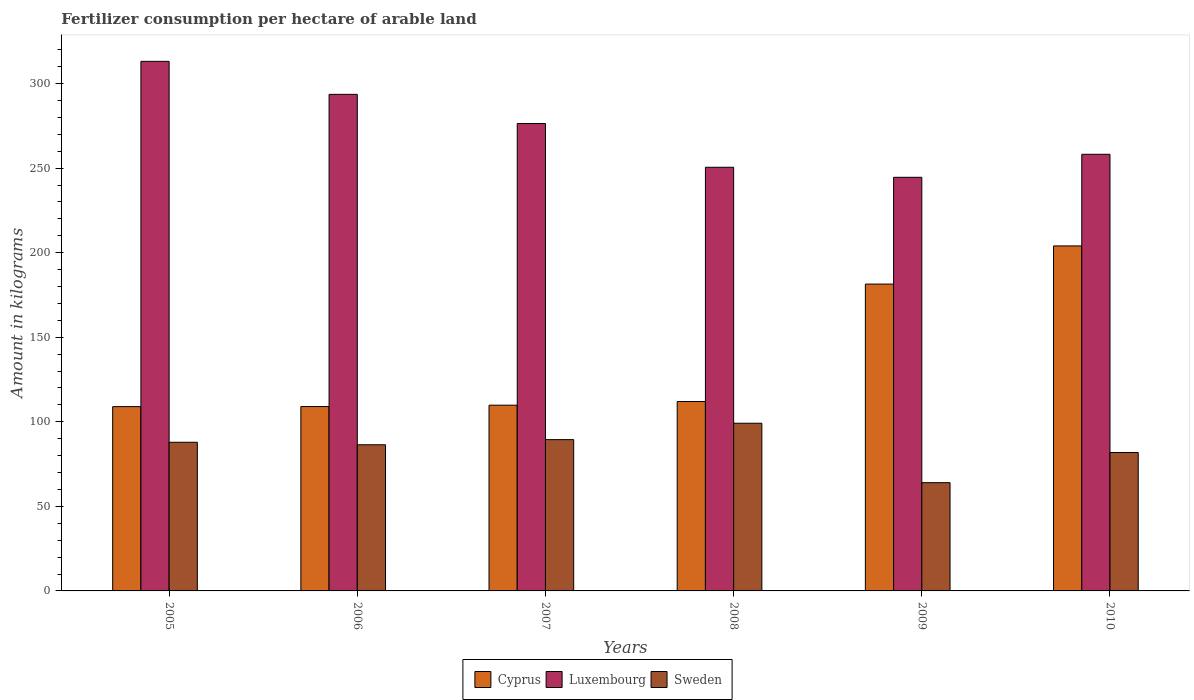How many different coloured bars are there?
Offer a terse response. 3. Are the number of bars per tick equal to the number of legend labels?
Ensure brevity in your answer.  Yes. How many bars are there on the 5th tick from the left?
Your response must be concise. 3. In how many cases, is the number of bars for a given year not equal to the number of legend labels?
Your response must be concise. 0. What is the amount of fertilizer consumption in Luxembourg in 2007?
Offer a terse response. 276.41. Across all years, what is the maximum amount of fertilizer consumption in Cyprus?
Provide a succinct answer. 204.01. Across all years, what is the minimum amount of fertilizer consumption in Cyprus?
Provide a succinct answer. 108.98. In which year was the amount of fertilizer consumption in Cyprus maximum?
Your answer should be compact. 2010. What is the total amount of fertilizer consumption in Cyprus in the graph?
Keep it short and to the point. 825.31. What is the difference between the amount of fertilizer consumption in Sweden in 2007 and that in 2010?
Your response must be concise. 7.61. What is the difference between the amount of fertilizer consumption in Luxembourg in 2008 and the amount of fertilizer consumption in Cyprus in 2005?
Offer a terse response. 141.54. What is the average amount of fertilizer consumption in Cyprus per year?
Ensure brevity in your answer.  137.55. In the year 2008, what is the difference between the amount of fertilizer consumption in Cyprus and amount of fertilizer consumption in Sweden?
Your answer should be very brief. 12.85. In how many years, is the amount of fertilizer consumption in Luxembourg greater than 30 kg?
Offer a very short reply. 6. What is the ratio of the amount of fertilizer consumption in Cyprus in 2006 to that in 2007?
Offer a very short reply. 0.99. Is the amount of fertilizer consumption in Luxembourg in 2005 less than that in 2009?
Offer a terse response. No. What is the difference between the highest and the second highest amount of fertilizer consumption in Luxembourg?
Your answer should be very brief. 19.52. What is the difference between the highest and the lowest amount of fertilizer consumption in Sweden?
Provide a succinct answer. 35.15. In how many years, is the amount of fertilizer consumption in Luxembourg greater than the average amount of fertilizer consumption in Luxembourg taken over all years?
Give a very brief answer. 3. Is the sum of the amount of fertilizer consumption in Sweden in 2006 and 2008 greater than the maximum amount of fertilizer consumption in Cyprus across all years?
Make the answer very short. No. How many years are there in the graph?
Make the answer very short. 6. What is the difference between two consecutive major ticks on the Y-axis?
Provide a short and direct response. 50. Are the values on the major ticks of Y-axis written in scientific E-notation?
Your response must be concise. No. Does the graph contain any zero values?
Provide a short and direct response. No. Where does the legend appear in the graph?
Your answer should be compact. Bottom center. What is the title of the graph?
Make the answer very short. Fertilizer consumption per hectare of arable land. Does "Bangladesh" appear as one of the legend labels in the graph?
Keep it short and to the point. No. What is the label or title of the X-axis?
Provide a succinct answer. Years. What is the label or title of the Y-axis?
Ensure brevity in your answer.  Amount in kilograms. What is the Amount in kilograms in Cyprus in 2005?
Ensure brevity in your answer.  108.98. What is the Amount in kilograms of Luxembourg in 2005?
Offer a terse response. 313.15. What is the Amount in kilograms of Sweden in 2005?
Your response must be concise. 87.9. What is the Amount in kilograms of Cyprus in 2006?
Your response must be concise. 109.03. What is the Amount in kilograms of Luxembourg in 2006?
Provide a succinct answer. 293.63. What is the Amount in kilograms of Sweden in 2006?
Provide a short and direct response. 86.42. What is the Amount in kilograms of Cyprus in 2007?
Give a very brief answer. 109.84. What is the Amount in kilograms of Luxembourg in 2007?
Your answer should be compact. 276.41. What is the Amount in kilograms of Sweden in 2007?
Keep it short and to the point. 89.47. What is the Amount in kilograms in Cyprus in 2008?
Your answer should be compact. 112.01. What is the Amount in kilograms of Luxembourg in 2008?
Make the answer very short. 250.52. What is the Amount in kilograms in Sweden in 2008?
Offer a terse response. 99.16. What is the Amount in kilograms of Cyprus in 2009?
Provide a short and direct response. 181.45. What is the Amount in kilograms of Luxembourg in 2009?
Make the answer very short. 244.58. What is the Amount in kilograms in Sweden in 2009?
Give a very brief answer. 64.01. What is the Amount in kilograms of Cyprus in 2010?
Keep it short and to the point. 204.01. What is the Amount in kilograms of Luxembourg in 2010?
Your answer should be very brief. 258.19. What is the Amount in kilograms in Sweden in 2010?
Provide a succinct answer. 81.85. Across all years, what is the maximum Amount in kilograms in Cyprus?
Offer a very short reply. 204.01. Across all years, what is the maximum Amount in kilograms in Luxembourg?
Ensure brevity in your answer.  313.15. Across all years, what is the maximum Amount in kilograms of Sweden?
Offer a very short reply. 99.16. Across all years, what is the minimum Amount in kilograms of Cyprus?
Keep it short and to the point. 108.98. Across all years, what is the minimum Amount in kilograms in Luxembourg?
Your answer should be compact. 244.58. Across all years, what is the minimum Amount in kilograms in Sweden?
Make the answer very short. 64.01. What is the total Amount in kilograms in Cyprus in the graph?
Your answer should be very brief. 825.31. What is the total Amount in kilograms of Luxembourg in the graph?
Provide a short and direct response. 1636.49. What is the total Amount in kilograms in Sweden in the graph?
Give a very brief answer. 508.81. What is the difference between the Amount in kilograms of Cyprus in 2005 and that in 2006?
Your answer should be compact. -0.05. What is the difference between the Amount in kilograms of Luxembourg in 2005 and that in 2006?
Your answer should be compact. 19.52. What is the difference between the Amount in kilograms of Sweden in 2005 and that in 2006?
Offer a terse response. 1.48. What is the difference between the Amount in kilograms of Cyprus in 2005 and that in 2007?
Your answer should be very brief. -0.86. What is the difference between the Amount in kilograms in Luxembourg in 2005 and that in 2007?
Make the answer very short. 36.74. What is the difference between the Amount in kilograms in Sweden in 2005 and that in 2007?
Ensure brevity in your answer.  -1.57. What is the difference between the Amount in kilograms in Cyprus in 2005 and that in 2008?
Offer a terse response. -3.04. What is the difference between the Amount in kilograms of Luxembourg in 2005 and that in 2008?
Keep it short and to the point. 62.63. What is the difference between the Amount in kilograms of Sweden in 2005 and that in 2008?
Give a very brief answer. -11.26. What is the difference between the Amount in kilograms in Cyprus in 2005 and that in 2009?
Make the answer very short. -72.47. What is the difference between the Amount in kilograms in Luxembourg in 2005 and that in 2009?
Your response must be concise. 68.57. What is the difference between the Amount in kilograms of Sweden in 2005 and that in 2009?
Give a very brief answer. 23.89. What is the difference between the Amount in kilograms of Cyprus in 2005 and that in 2010?
Offer a very short reply. -95.03. What is the difference between the Amount in kilograms of Luxembourg in 2005 and that in 2010?
Give a very brief answer. 54.96. What is the difference between the Amount in kilograms in Sweden in 2005 and that in 2010?
Your answer should be very brief. 6.04. What is the difference between the Amount in kilograms of Cyprus in 2006 and that in 2007?
Make the answer very short. -0.81. What is the difference between the Amount in kilograms of Luxembourg in 2006 and that in 2007?
Offer a terse response. 17.22. What is the difference between the Amount in kilograms in Sweden in 2006 and that in 2007?
Offer a terse response. -3.05. What is the difference between the Amount in kilograms in Cyprus in 2006 and that in 2008?
Give a very brief answer. -2.99. What is the difference between the Amount in kilograms of Luxembourg in 2006 and that in 2008?
Offer a terse response. 43.12. What is the difference between the Amount in kilograms in Sweden in 2006 and that in 2008?
Offer a very short reply. -12.74. What is the difference between the Amount in kilograms of Cyprus in 2006 and that in 2009?
Offer a very short reply. -72.42. What is the difference between the Amount in kilograms in Luxembourg in 2006 and that in 2009?
Your answer should be compact. 49.05. What is the difference between the Amount in kilograms in Sweden in 2006 and that in 2009?
Offer a very short reply. 22.41. What is the difference between the Amount in kilograms in Cyprus in 2006 and that in 2010?
Keep it short and to the point. -94.98. What is the difference between the Amount in kilograms of Luxembourg in 2006 and that in 2010?
Provide a succinct answer. 35.44. What is the difference between the Amount in kilograms of Sweden in 2006 and that in 2010?
Ensure brevity in your answer.  4.57. What is the difference between the Amount in kilograms of Cyprus in 2007 and that in 2008?
Ensure brevity in your answer.  -2.18. What is the difference between the Amount in kilograms of Luxembourg in 2007 and that in 2008?
Give a very brief answer. 25.89. What is the difference between the Amount in kilograms in Sweden in 2007 and that in 2008?
Your response must be concise. -9.7. What is the difference between the Amount in kilograms of Cyprus in 2007 and that in 2009?
Make the answer very short. -71.61. What is the difference between the Amount in kilograms in Luxembourg in 2007 and that in 2009?
Keep it short and to the point. 31.83. What is the difference between the Amount in kilograms in Sweden in 2007 and that in 2009?
Offer a terse response. 25.46. What is the difference between the Amount in kilograms in Cyprus in 2007 and that in 2010?
Ensure brevity in your answer.  -94.17. What is the difference between the Amount in kilograms of Luxembourg in 2007 and that in 2010?
Keep it short and to the point. 18.22. What is the difference between the Amount in kilograms of Sweden in 2007 and that in 2010?
Give a very brief answer. 7.61. What is the difference between the Amount in kilograms in Cyprus in 2008 and that in 2009?
Give a very brief answer. -69.44. What is the difference between the Amount in kilograms of Luxembourg in 2008 and that in 2009?
Your answer should be compact. 5.93. What is the difference between the Amount in kilograms of Sweden in 2008 and that in 2009?
Your answer should be very brief. 35.15. What is the difference between the Amount in kilograms of Cyprus in 2008 and that in 2010?
Ensure brevity in your answer.  -91.99. What is the difference between the Amount in kilograms of Luxembourg in 2008 and that in 2010?
Make the answer very short. -7.68. What is the difference between the Amount in kilograms of Sweden in 2008 and that in 2010?
Your answer should be very brief. 17.31. What is the difference between the Amount in kilograms of Cyprus in 2009 and that in 2010?
Provide a succinct answer. -22.56. What is the difference between the Amount in kilograms in Luxembourg in 2009 and that in 2010?
Give a very brief answer. -13.61. What is the difference between the Amount in kilograms in Sweden in 2009 and that in 2010?
Provide a short and direct response. -17.85. What is the difference between the Amount in kilograms in Cyprus in 2005 and the Amount in kilograms in Luxembourg in 2006?
Keep it short and to the point. -184.66. What is the difference between the Amount in kilograms in Cyprus in 2005 and the Amount in kilograms in Sweden in 2006?
Your answer should be compact. 22.56. What is the difference between the Amount in kilograms in Luxembourg in 2005 and the Amount in kilograms in Sweden in 2006?
Keep it short and to the point. 226.73. What is the difference between the Amount in kilograms in Cyprus in 2005 and the Amount in kilograms in Luxembourg in 2007?
Your answer should be very brief. -167.43. What is the difference between the Amount in kilograms in Cyprus in 2005 and the Amount in kilograms in Sweden in 2007?
Provide a short and direct response. 19.51. What is the difference between the Amount in kilograms of Luxembourg in 2005 and the Amount in kilograms of Sweden in 2007?
Make the answer very short. 223.68. What is the difference between the Amount in kilograms in Cyprus in 2005 and the Amount in kilograms in Luxembourg in 2008?
Make the answer very short. -141.54. What is the difference between the Amount in kilograms of Cyprus in 2005 and the Amount in kilograms of Sweden in 2008?
Ensure brevity in your answer.  9.81. What is the difference between the Amount in kilograms of Luxembourg in 2005 and the Amount in kilograms of Sweden in 2008?
Your answer should be compact. 213.99. What is the difference between the Amount in kilograms in Cyprus in 2005 and the Amount in kilograms in Luxembourg in 2009?
Provide a short and direct response. -135.61. What is the difference between the Amount in kilograms in Cyprus in 2005 and the Amount in kilograms in Sweden in 2009?
Your answer should be compact. 44.97. What is the difference between the Amount in kilograms of Luxembourg in 2005 and the Amount in kilograms of Sweden in 2009?
Provide a succinct answer. 249.14. What is the difference between the Amount in kilograms of Cyprus in 2005 and the Amount in kilograms of Luxembourg in 2010?
Your response must be concise. -149.22. What is the difference between the Amount in kilograms in Cyprus in 2005 and the Amount in kilograms in Sweden in 2010?
Provide a short and direct response. 27.12. What is the difference between the Amount in kilograms in Luxembourg in 2005 and the Amount in kilograms in Sweden in 2010?
Your answer should be compact. 231.3. What is the difference between the Amount in kilograms of Cyprus in 2006 and the Amount in kilograms of Luxembourg in 2007?
Ensure brevity in your answer.  -167.38. What is the difference between the Amount in kilograms of Cyprus in 2006 and the Amount in kilograms of Sweden in 2007?
Make the answer very short. 19.56. What is the difference between the Amount in kilograms in Luxembourg in 2006 and the Amount in kilograms in Sweden in 2007?
Ensure brevity in your answer.  204.17. What is the difference between the Amount in kilograms in Cyprus in 2006 and the Amount in kilograms in Luxembourg in 2008?
Keep it short and to the point. -141.49. What is the difference between the Amount in kilograms in Cyprus in 2006 and the Amount in kilograms in Sweden in 2008?
Give a very brief answer. 9.86. What is the difference between the Amount in kilograms in Luxembourg in 2006 and the Amount in kilograms in Sweden in 2008?
Your response must be concise. 194.47. What is the difference between the Amount in kilograms of Cyprus in 2006 and the Amount in kilograms of Luxembourg in 2009?
Make the answer very short. -135.56. What is the difference between the Amount in kilograms in Cyprus in 2006 and the Amount in kilograms in Sweden in 2009?
Offer a terse response. 45.02. What is the difference between the Amount in kilograms in Luxembourg in 2006 and the Amount in kilograms in Sweden in 2009?
Offer a very short reply. 229.62. What is the difference between the Amount in kilograms in Cyprus in 2006 and the Amount in kilograms in Luxembourg in 2010?
Provide a succinct answer. -149.17. What is the difference between the Amount in kilograms in Cyprus in 2006 and the Amount in kilograms in Sweden in 2010?
Offer a terse response. 27.17. What is the difference between the Amount in kilograms in Luxembourg in 2006 and the Amount in kilograms in Sweden in 2010?
Give a very brief answer. 211.78. What is the difference between the Amount in kilograms in Cyprus in 2007 and the Amount in kilograms in Luxembourg in 2008?
Your answer should be compact. -140.68. What is the difference between the Amount in kilograms in Cyprus in 2007 and the Amount in kilograms in Sweden in 2008?
Give a very brief answer. 10.67. What is the difference between the Amount in kilograms of Luxembourg in 2007 and the Amount in kilograms of Sweden in 2008?
Your response must be concise. 177.25. What is the difference between the Amount in kilograms of Cyprus in 2007 and the Amount in kilograms of Luxembourg in 2009?
Make the answer very short. -134.75. What is the difference between the Amount in kilograms in Cyprus in 2007 and the Amount in kilograms in Sweden in 2009?
Your response must be concise. 45.83. What is the difference between the Amount in kilograms in Luxembourg in 2007 and the Amount in kilograms in Sweden in 2009?
Make the answer very short. 212.4. What is the difference between the Amount in kilograms of Cyprus in 2007 and the Amount in kilograms of Luxembourg in 2010?
Provide a short and direct response. -148.36. What is the difference between the Amount in kilograms of Cyprus in 2007 and the Amount in kilograms of Sweden in 2010?
Give a very brief answer. 27.98. What is the difference between the Amount in kilograms in Luxembourg in 2007 and the Amount in kilograms in Sweden in 2010?
Provide a succinct answer. 194.56. What is the difference between the Amount in kilograms in Cyprus in 2008 and the Amount in kilograms in Luxembourg in 2009?
Make the answer very short. -132.57. What is the difference between the Amount in kilograms in Cyprus in 2008 and the Amount in kilograms in Sweden in 2009?
Make the answer very short. 48.01. What is the difference between the Amount in kilograms of Luxembourg in 2008 and the Amount in kilograms of Sweden in 2009?
Provide a short and direct response. 186.51. What is the difference between the Amount in kilograms of Cyprus in 2008 and the Amount in kilograms of Luxembourg in 2010?
Offer a very short reply. -146.18. What is the difference between the Amount in kilograms of Cyprus in 2008 and the Amount in kilograms of Sweden in 2010?
Your answer should be compact. 30.16. What is the difference between the Amount in kilograms in Luxembourg in 2008 and the Amount in kilograms in Sweden in 2010?
Provide a short and direct response. 168.66. What is the difference between the Amount in kilograms in Cyprus in 2009 and the Amount in kilograms in Luxembourg in 2010?
Your response must be concise. -76.74. What is the difference between the Amount in kilograms of Cyprus in 2009 and the Amount in kilograms of Sweden in 2010?
Keep it short and to the point. 99.6. What is the difference between the Amount in kilograms of Luxembourg in 2009 and the Amount in kilograms of Sweden in 2010?
Keep it short and to the point. 162.73. What is the average Amount in kilograms of Cyprus per year?
Your answer should be very brief. 137.55. What is the average Amount in kilograms in Luxembourg per year?
Offer a very short reply. 272.75. What is the average Amount in kilograms in Sweden per year?
Offer a very short reply. 84.8. In the year 2005, what is the difference between the Amount in kilograms in Cyprus and Amount in kilograms in Luxembourg?
Make the answer very short. -204.17. In the year 2005, what is the difference between the Amount in kilograms of Cyprus and Amount in kilograms of Sweden?
Your answer should be very brief. 21.08. In the year 2005, what is the difference between the Amount in kilograms of Luxembourg and Amount in kilograms of Sweden?
Offer a very short reply. 225.25. In the year 2006, what is the difference between the Amount in kilograms in Cyprus and Amount in kilograms in Luxembourg?
Keep it short and to the point. -184.61. In the year 2006, what is the difference between the Amount in kilograms of Cyprus and Amount in kilograms of Sweden?
Offer a terse response. 22.61. In the year 2006, what is the difference between the Amount in kilograms of Luxembourg and Amount in kilograms of Sweden?
Your answer should be compact. 207.21. In the year 2007, what is the difference between the Amount in kilograms in Cyprus and Amount in kilograms in Luxembourg?
Your response must be concise. -166.57. In the year 2007, what is the difference between the Amount in kilograms of Cyprus and Amount in kilograms of Sweden?
Your answer should be compact. 20.37. In the year 2007, what is the difference between the Amount in kilograms in Luxembourg and Amount in kilograms in Sweden?
Keep it short and to the point. 186.94. In the year 2008, what is the difference between the Amount in kilograms of Cyprus and Amount in kilograms of Luxembourg?
Give a very brief answer. -138.5. In the year 2008, what is the difference between the Amount in kilograms in Cyprus and Amount in kilograms in Sweden?
Make the answer very short. 12.85. In the year 2008, what is the difference between the Amount in kilograms of Luxembourg and Amount in kilograms of Sweden?
Provide a succinct answer. 151.35. In the year 2009, what is the difference between the Amount in kilograms of Cyprus and Amount in kilograms of Luxembourg?
Your answer should be very brief. -63.13. In the year 2009, what is the difference between the Amount in kilograms in Cyprus and Amount in kilograms in Sweden?
Your answer should be compact. 117.44. In the year 2009, what is the difference between the Amount in kilograms in Luxembourg and Amount in kilograms in Sweden?
Keep it short and to the point. 180.58. In the year 2010, what is the difference between the Amount in kilograms in Cyprus and Amount in kilograms in Luxembourg?
Offer a terse response. -54.18. In the year 2010, what is the difference between the Amount in kilograms of Cyprus and Amount in kilograms of Sweden?
Make the answer very short. 122.15. In the year 2010, what is the difference between the Amount in kilograms in Luxembourg and Amount in kilograms in Sweden?
Ensure brevity in your answer.  176.34. What is the ratio of the Amount in kilograms in Luxembourg in 2005 to that in 2006?
Ensure brevity in your answer.  1.07. What is the ratio of the Amount in kilograms in Sweden in 2005 to that in 2006?
Make the answer very short. 1.02. What is the ratio of the Amount in kilograms in Cyprus in 2005 to that in 2007?
Offer a terse response. 0.99. What is the ratio of the Amount in kilograms in Luxembourg in 2005 to that in 2007?
Your response must be concise. 1.13. What is the ratio of the Amount in kilograms in Sweden in 2005 to that in 2007?
Offer a very short reply. 0.98. What is the ratio of the Amount in kilograms in Cyprus in 2005 to that in 2008?
Offer a terse response. 0.97. What is the ratio of the Amount in kilograms of Sweden in 2005 to that in 2008?
Ensure brevity in your answer.  0.89. What is the ratio of the Amount in kilograms of Cyprus in 2005 to that in 2009?
Offer a very short reply. 0.6. What is the ratio of the Amount in kilograms in Luxembourg in 2005 to that in 2009?
Your response must be concise. 1.28. What is the ratio of the Amount in kilograms in Sweden in 2005 to that in 2009?
Provide a short and direct response. 1.37. What is the ratio of the Amount in kilograms of Cyprus in 2005 to that in 2010?
Offer a very short reply. 0.53. What is the ratio of the Amount in kilograms of Luxembourg in 2005 to that in 2010?
Offer a very short reply. 1.21. What is the ratio of the Amount in kilograms of Sweden in 2005 to that in 2010?
Provide a succinct answer. 1.07. What is the ratio of the Amount in kilograms of Luxembourg in 2006 to that in 2007?
Provide a succinct answer. 1.06. What is the ratio of the Amount in kilograms of Sweden in 2006 to that in 2007?
Offer a very short reply. 0.97. What is the ratio of the Amount in kilograms in Cyprus in 2006 to that in 2008?
Offer a very short reply. 0.97. What is the ratio of the Amount in kilograms of Luxembourg in 2006 to that in 2008?
Provide a succinct answer. 1.17. What is the ratio of the Amount in kilograms in Sweden in 2006 to that in 2008?
Your answer should be compact. 0.87. What is the ratio of the Amount in kilograms in Cyprus in 2006 to that in 2009?
Your response must be concise. 0.6. What is the ratio of the Amount in kilograms of Luxembourg in 2006 to that in 2009?
Ensure brevity in your answer.  1.2. What is the ratio of the Amount in kilograms of Sweden in 2006 to that in 2009?
Keep it short and to the point. 1.35. What is the ratio of the Amount in kilograms of Cyprus in 2006 to that in 2010?
Offer a terse response. 0.53. What is the ratio of the Amount in kilograms of Luxembourg in 2006 to that in 2010?
Give a very brief answer. 1.14. What is the ratio of the Amount in kilograms of Sweden in 2006 to that in 2010?
Your response must be concise. 1.06. What is the ratio of the Amount in kilograms of Cyprus in 2007 to that in 2008?
Ensure brevity in your answer.  0.98. What is the ratio of the Amount in kilograms in Luxembourg in 2007 to that in 2008?
Your answer should be compact. 1.1. What is the ratio of the Amount in kilograms of Sweden in 2007 to that in 2008?
Offer a very short reply. 0.9. What is the ratio of the Amount in kilograms of Cyprus in 2007 to that in 2009?
Your answer should be compact. 0.61. What is the ratio of the Amount in kilograms of Luxembourg in 2007 to that in 2009?
Provide a succinct answer. 1.13. What is the ratio of the Amount in kilograms of Sweden in 2007 to that in 2009?
Make the answer very short. 1.4. What is the ratio of the Amount in kilograms of Cyprus in 2007 to that in 2010?
Make the answer very short. 0.54. What is the ratio of the Amount in kilograms of Luxembourg in 2007 to that in 2010?
Make the answer very short. 1.07. What is the ratio of the Amount in kilograms of Sweden in 2007 to that in 2010?
Offer a terse response. 1.09. What is the ratio of the Amount in kilograms of Cyprus in 2008 to that in 2009?
Offer a very short reply. 0.62. What is the ratio of the Amount in kilograms of Luxembourg in 2008 to that in 2009?
Ensure brevity in your answer.  1.02. What is the ratio of the Amount in kilograms of Sweden in 2008 to that in 2009?
Provide a short and direct response. 1.55. What is the ratio of the Amount in kilograms of Cyprus in 2008 to that in 2010?
Your answer should be very brief. 0.55. What is the ratio of the Amount in kilograms of Luxembourg in 2008 to that in 2010?
Offer a very short reply. 0.97. What is the ratio of the Amount in kilograms of Sweden in 2008 to that in 2010?
Ensure brevity in your answer.  1.21. What is the ratio of the Amount in kilograms of Cyprus in 2009 to that in 2010?
Make the answer very short. 0.89. What is the ratio of the Amount in kilograms of Luxembourg in 2009 to that in 2010?
Make the answer very short. 0.95. What is the ratio of the Amount in kilograms in Sweden in 2009 to that in 2010?
Your answer should be very brief. 0.78. What is the difference between the highest and the second highest Amount in kilograms of Cyprus?
Your answer should be very brief. 22.56. What is the difference between the highest and the second highest Amount in kilograms of Luxembourg?
Offer a terse response. 19.52. What is the difference between the highest and the second highest Amount in kilograms of Sweden?
Offer a very short reply. 9.7. What is the difference between the highest and the lowest Amount in kilograms in Cyprus?
Your answer should be compact. 95.03. What is the difference between the highest and the lowest Amount in kilograms of Luxembourg?
Your response must be concise. 68.57. What is the difference between the highest and the lowest Amount in kilograms of Sweden?
Offer a very short reply. 35.15. 